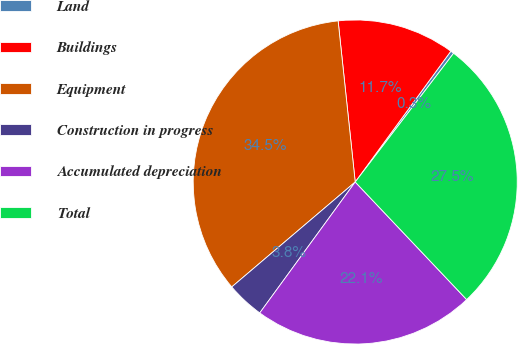Convert chart. <chart><loc_0><loc_0><loc_500><loc_500><pie_chart><fcel>Land<fcel>Buildings<fcel>Equipment<fcel>Construction in progress<fcel>Accumulated depreciation<fcel>Total<nl><fcel>0.34%<fcel>11.73%<fcel>34.53%<fcel>3.76%<fcel>22.1%<fcel>27.54%<nl></chart> 